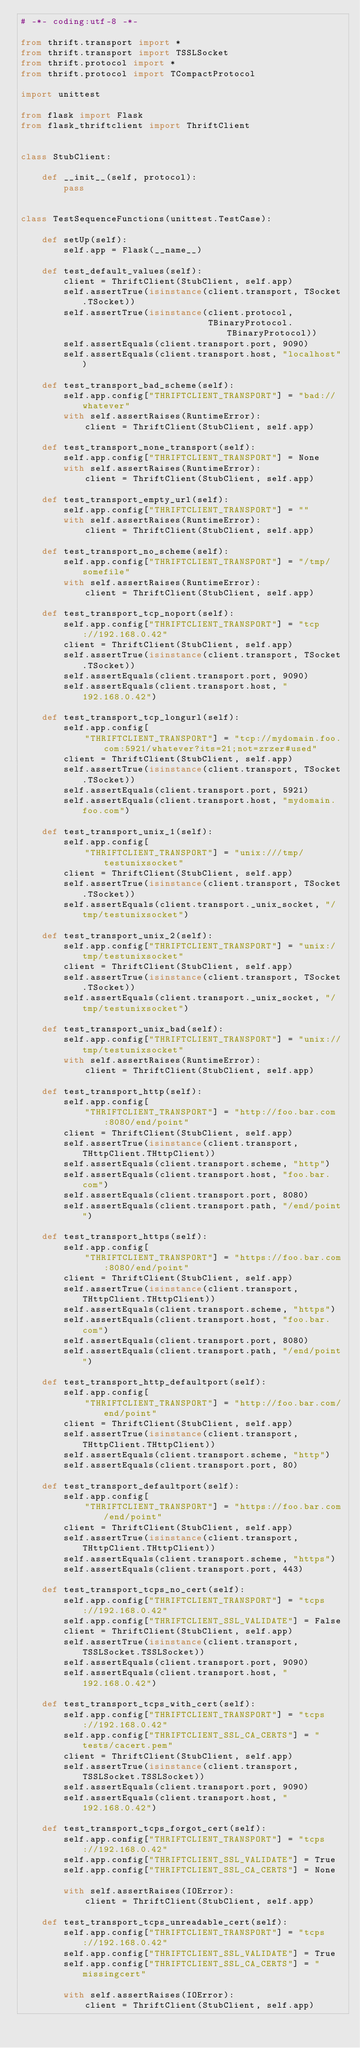Convert code to text. <code><loc_0><loc_0><loc_500><loc_500><_Python_># -*- coding:utf-8 -*-

from thrift.transport import *
from thrift.transport import TSSLSocket
from thrift.protocol import *
from thrift.protocol import TCompactProtocol

import unittest

from flask import Flask
from flask_thriftclient import ThriftClient


class StubClient:

    def __init__(self, protocol):
        pass


class TestSequenceFunctions(unittest.TestCase):

    def setUp(self):
        self.app = Flask(__name__)

    def test_default_values(self):
        client = ThriftClient(StubClient, self.app)
        self.assertTrue(isinstance(client.transport, TSocket.TSocket))
        self.assertTrue(isinstance(client.protocol,
                                   TBinaryProtocol.TBinaryProtocol))
        self.assertEquals(client.transport.port, 9090)
        self.assertEquals(client.transport.host, "localhost")

    def test_transport_bad_scheme(self):
        self.app.config["THRIFTCLIENT_TRANSPORT"] = "bad://whatever"
        with self.assertRaises(RuntimeError):
            client = ThriftClient(StubClient, self.app)

    def test_transport_none_transport(self):
        self.app.config["THRIFTCLIENT_TRANSPORT"] = None
        with self.assertRaises(RuntimeError):
            client = ThriftClient(StubClient, self.app)

    def test_transport_empty_url(self):
        self.app.config["THRIFTCLIENT_TRANSPORT"] = ""
        with self.assertRaises(RuntimeError):
            client = ThriftClient(StubClient, self.app)

    def test_transport_no_scheme(self):
        self.app.config["THRIFTCLIENT_TRANSPORT"] = "/tmp/somefile"
        with self.assertRaises(RuntimeError):
            client = ThriftClient(StubClient, self.app)

    def test_transport_tcp_noport(self):
        self.app.config["THRIFTCLIENT_TRANSPORT"] = "tcp://192.168.0.42"
        client = ThriftClient(StubClient, self.app)
        self.assertTrue(isinstance(client.transport, TSocket.TSocket))
        self.assertEquals(client.transport.port, 9090)
        self.assertEquals(client.transport.host, "192.168.0.42")

    def test_transport_tcp_longurl(self):
        self.app.config[
            "THRIFTCLIENT_TRANSPORT"] = "tcp://mydomain.foo.com:5921/whatever?its=21;not=zrzer#used"
        client = ThriftClient(StubClient, self.app)
        self.assertTrue(isinstance(client.transport, TSocket.TSocket))
        self.assertEquals(client.transport.port, 5921)
        self.assertEquals(client.transport.host, "mydomain.foo.com")

    def test_transport_unix_1(self):
        self.app.config[
            "THRIFTCLIENT_TRANSPORT"] = "unix:///tmp/testunixsocket"
        client = ThriftClient(StubClient, self.app)
        self.assertTrue(isinstance(client.transport, TSocket.TSocket))
        self.assertEquals(client.transport._unix_socket, "/tmp/testunixsocket")

    def test_transport_unix_2(self):
        self.app.config["THRIFTCLIENT_TRANSPORT"] = "unix:/tmp/testunixsocket"
        client = ThriftClient(StubClient, self.app)
        self.assertTrue(isinstance(client.transport, TSocket.TSocket))
        self.assertEquals(client.transport._unix_socket, "/tmp/testunixsocket")

    def test_transport_unix_bad(self):
        self.app.config["THRIFTCLIENT_TRANSPORT"] = "unix://tmp/testunixsocket"
        with self.assertRaises(RuntimeError):
            client = ThriftClient(StubClient, self.app)

    def test_transport_http(self):
        self.app.config[
            "THRIFTCLIENT_TRANSPORT"] = "http://foo.bar.com:8080/end/point"
        client = ThriftClient(StubClient, self.app)
        self.assertTrue(isinstance(client.transport, THttpClient.THttpClient))
        self.assertEquals(client.transport.scheme, "http")
        self.assertEquals(client.transport.host, "foo.bar.com")
        self.assertEquals(client.transport.port, 8080)
        self.assertEquals(client.transport.path, "/end/point")

    def test_transport_https(self):
        self.app.config[
            "THRIFTCLIENT_TRANSPORT"] = "https://foo.bar.com:8080/end/point"
        client = ThriftClient(StubClient, self.app)
        self.assertTrue(isinstance(client.transport, THttpClient.THttpClient))
        self.assertEquals(client.transport.scheme, "https")
        self.assertEquals(client.transport.host, "foo.bar.com")
        self.assertEquals(client.transport.port, 8080)
        self.assertEquals(client.transport.path, "/end/point")

    def test_transport_http_defaultport(self):
        self.app.config[
            "THRIFTCLIENT_TRANSPORT"] = "http://foo.bar.com/end/point"
        client = ThriftClient(StubClient, self.app)
        self.assertTrue(isinstance(client.transport, THttpClient.THttpClient))
        self.assertEquals(client.transport.scheme, "http")
        self.assertEquals(client.transport.port, 80)

    def test_transport_defaultport(self):
        self.app.config[
            "THRIFTCLIENT_TRANSPORT"] = "https://foo.bar.com/end/point"
        client = ThriftClient(StubClient, self.app)
        self.assertTrue(isinstance(client.transport, THttpClient.THttpClient))
        self.assertEquals(client.transport.scheme, "https")
        self.assertEquals(client.transport.port, 443)

    def test_transport_tcps_no_cert(self):
        self.app.config["THRIFTCLIENT_TRANSPORT"] = "tcps://192.168.0.42"
        self.app.config["THRIFTCLIENT_SSL_VALIDATE"] = False
        client = ThriftClient(StubClient, self.app)
        self.assertTrue(isinstance(client.transport, TSSLSocket.TSSLSocket))
        self.assertEquals(client.transport.port, 9090)
        self.assertEquals(client.transport.host, "192.168.0.42")

    def test_transport_tcps_with_cert(self):
        self.app.config["THRIFTCLIENT_TRANSPORT"] = "tcps://192.168.0.42"
        self.app.config["THRIFTCLIENT_SSL_CA_CERTS"] = "tests/cacert.pem"
        client = ThriftClient(StubClient, self.app)
        self.assertTrue(isinstance(client.transport, TSSLSocket.TSSLSocket))
        self.assertEquals(client.transport.port, 9090)
        self.assertEquals(client.transport.host, "192.168.0.42")

    def test_transport_tcps_forgot_cert(self):
        self.app.config["THRIFTCLIENT_TRANSPORT"] = "tcps://192.168.0.42"
        self.app.config["THRIFTCLIENT_SSL_VALIDATE"] = True
        self.app.config["THRIFTCLIENT_SSL_CA_CERTS"] = None

        with self.assertRaises(IOError):
            client = ThriftClient(StubClient, self.app)

    def test_transport_tcps_unreadable_cert(self):
        self.app.config["THRIFTCLIENT_TRANSPORT"] = "tcps://192.168.0.42"
        self.app.config["THRIFTCLIENT_SSL_VALIDATE"] = True
        self.app.config["THRIFTCLIENT_SSL_CA_CERTS"] = "missingcert"

        with self.assertRaises(IOError):
            client = ThriftClient(StubClient, self.app)
</code> 